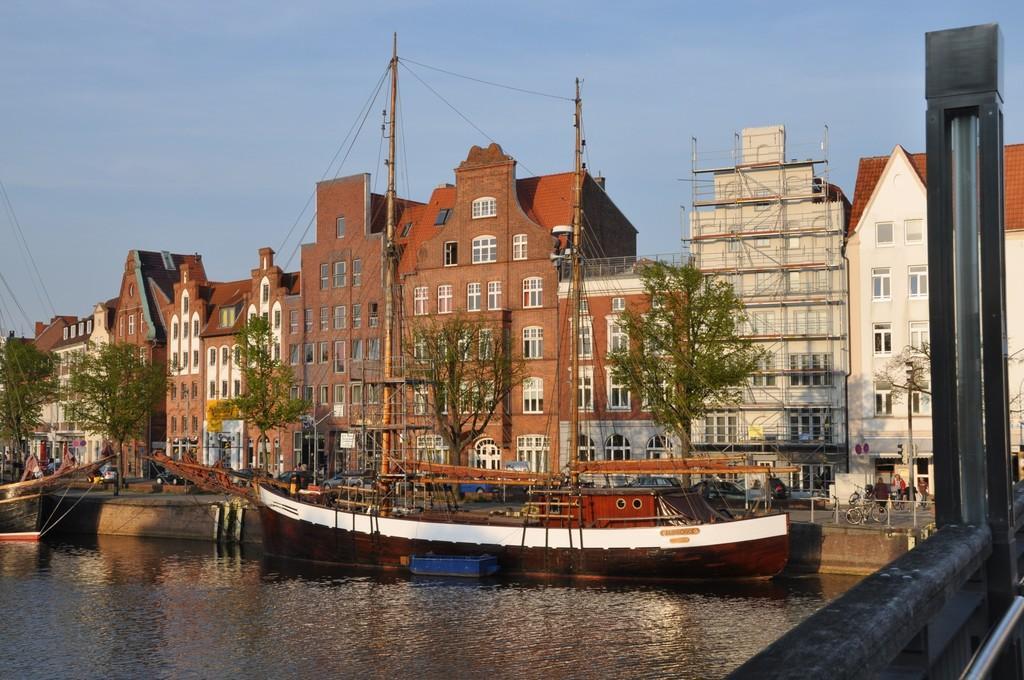Can you describe this image briefly? In this image I can see water and in it I can see few boats. In the background I can see few trees, few buildings, the sky and I can see few people over there. I can also see few poles and few wires. 